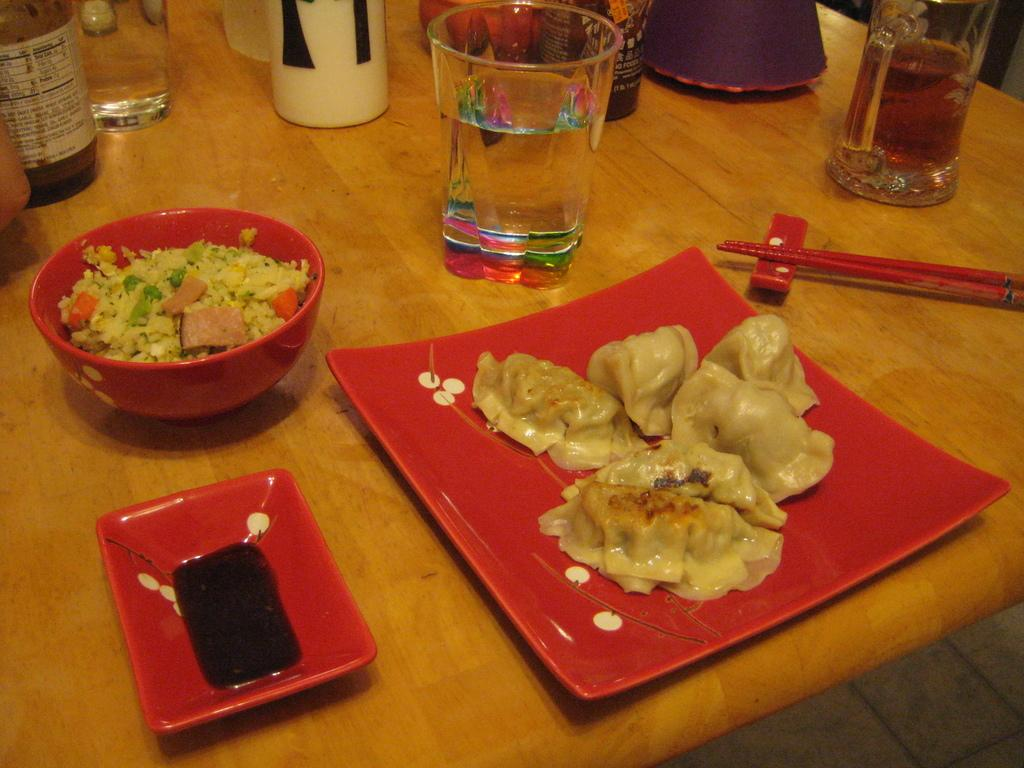What is on the table in the image? There is a glass, food, a plate, a bowl, and a bottle on the table in the image. What might be used for drinking in the image? The glass on the table might be used for drinking. What is the food placed on in the image? The food is placed on a plate in the image. What is the bowl used for in the image? The bowl might be used for holding a separate dish or condiments. What is the bottle likely to contain in the image? The bottle might contain a beverage or sauce. What type of sock is visible on the table in the image? There is no sock present on the table in the image. What animal can be seen interacting with the food on the plate in the image? There is no animal present in the image; it only shows objects on a table. 